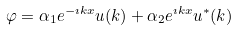Convert formula to latex. <formula><loc_0><loc_0><loc_500><loc_500>\varphi = \alpha _ { 1 } e ^ { - \imath k x } u ( k ) + \alpha _ { 2 } e ^ { \imath k x } u ^ { * } ( k )</formula> 